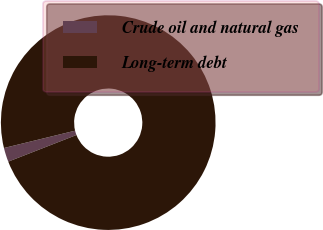Convert chart. <chart><loc_0><loc_0><loc_500><loc_500><pie_chart><fcel>Crude oil and natural gas<fcel>Long-term debt<nl><fcel>2.12%<fcel>97.88%<nl></chart> 